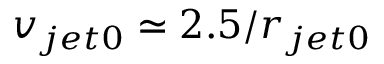Convert formula to latex. <formula><loc_0><loc_0><loc_500><loc_500>v _ { j e t 0 } \simeq 2 . 5 / r _ { j e t 0 }</formula> 